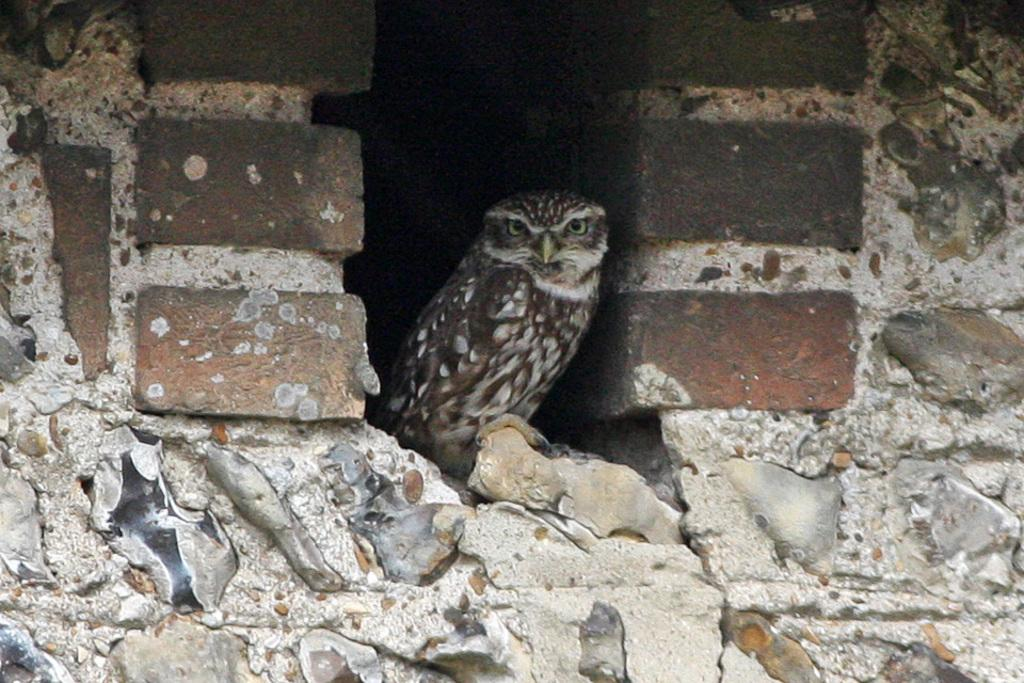What type of animal is in the image? There is a bird in the image. Can you describe the bird's coloring? The bird has brown and cream colors. What is the color of the background wall in the image? The background wall in the image has brown and cream colors. What type of payment is being made for the roof in the image? There is no roof or payment present in the image; it features a bird with brown and cream colors against a background wall with the same colors. 